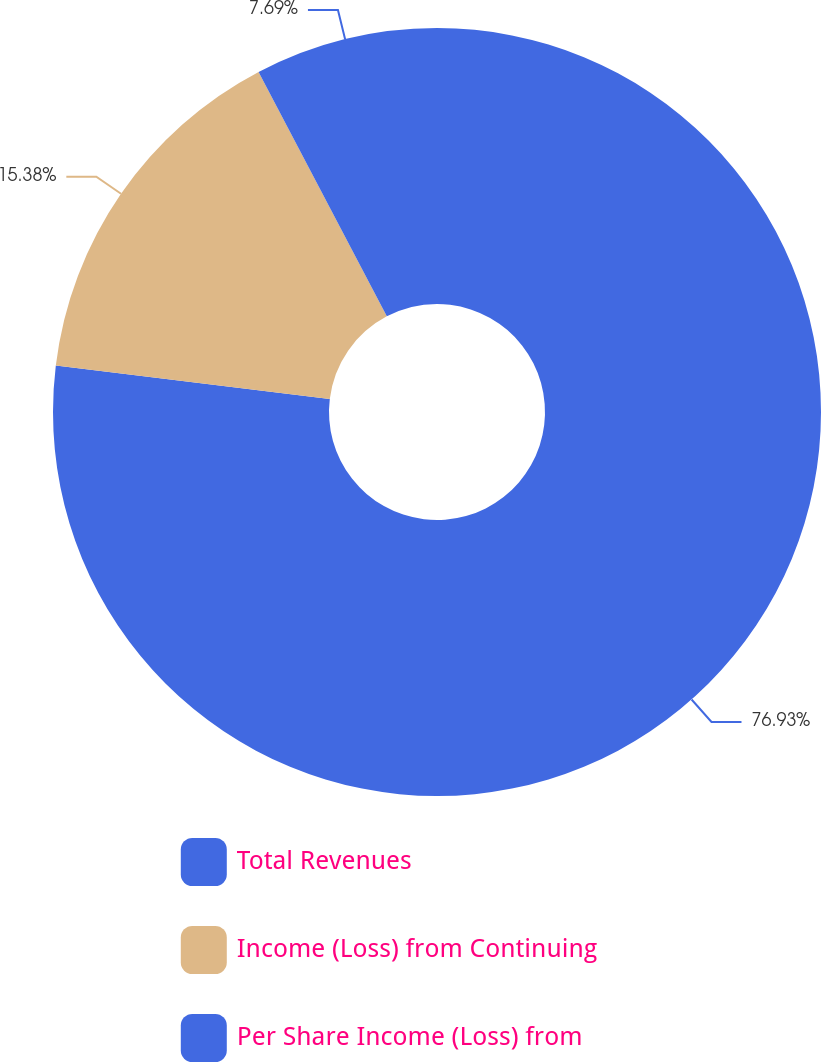Convert chart. <chart><loc_0><loc_0><loc_500><loc_500><pie_chart><fcel>Total Revenues<fcel>Income (Loss) from Continuing<fcel>Per Share Income (Loss) from<nl><fcel>76.92%<fcel>15.38%<fcel>7.69%<nl></chart> 